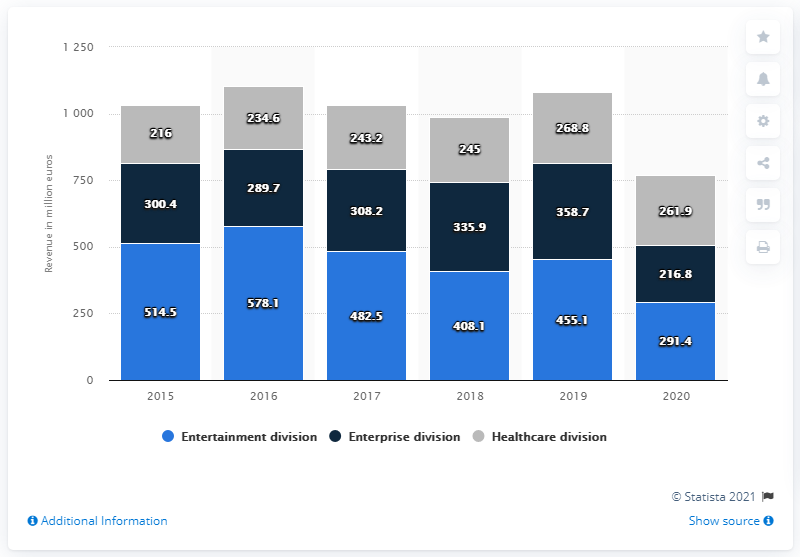Mention a couple of crucial points in this snapshot. In 2020, the entertainment division of Barco generated a total revenue of 291.4 million USD. 